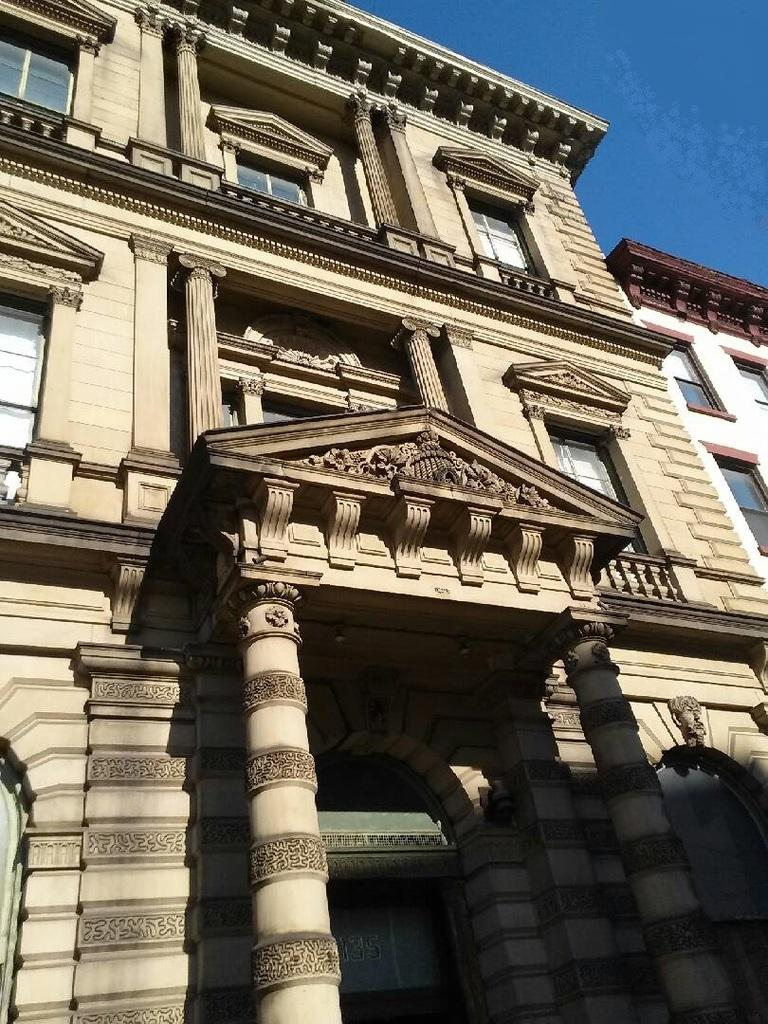What type of structures can be seen in the image? There are buildings in the image. What part of the natural environment is visible in the image? The sky is visible in the image. What type of juice can be seen flowing from the trees in the image? There are no trees or juice present in the image; it only features buildings and the sky. 